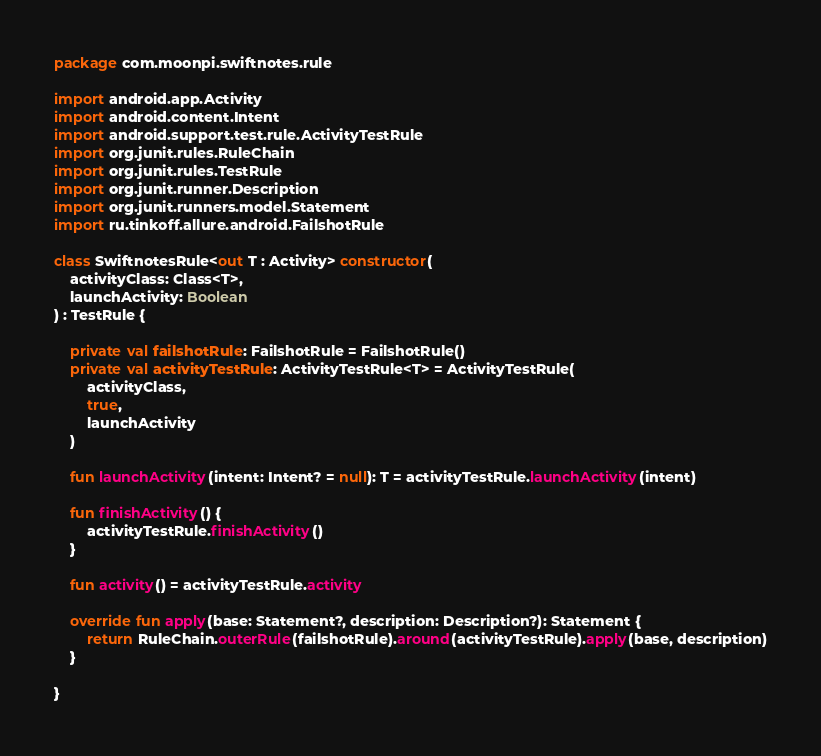Convert code to text. <code><loc_0><loc_0><loc_500><loc_500><_Kotlin_>package com.moonpi.swiftnotes.rule

import android.app.Activity
import android.content.Intent
import android.support.test.rule.ActivityTestRule
import org.junit.rules.RuleChain
import org.junit.rules.TestRule
import org.junit.runner.Description
import org.junit.runners.model.Statement
import ru.tinkoff.allure.android.FailshotRule

class SwiftnotesRule<out T : Activity> constructor(
    activityClass: Class<T>,
    launchActivity: Boolean
) : TestRule {

    private val failshotRule: FailshotRule = FailshotRule()
    private val activityTestRule: ActivityTestRule<T> = ActivityTestRule(
        activityClass,
        true,
        launchActivity
    )

    fun launchActivity(intent: Intent? = null): T = activityTestRule.launchActivity(intent)

    fun finishActivity() {
        activityTestRule.finishActivity()
    }

    fun activity() = activityTestRule.activity

    override fun apply(base: Statement?, description: Description?): Statement {
        return RuleChain.outerRule(failshotRule).around(activityTestRule).apply(base, description)
    }

}
</code> 